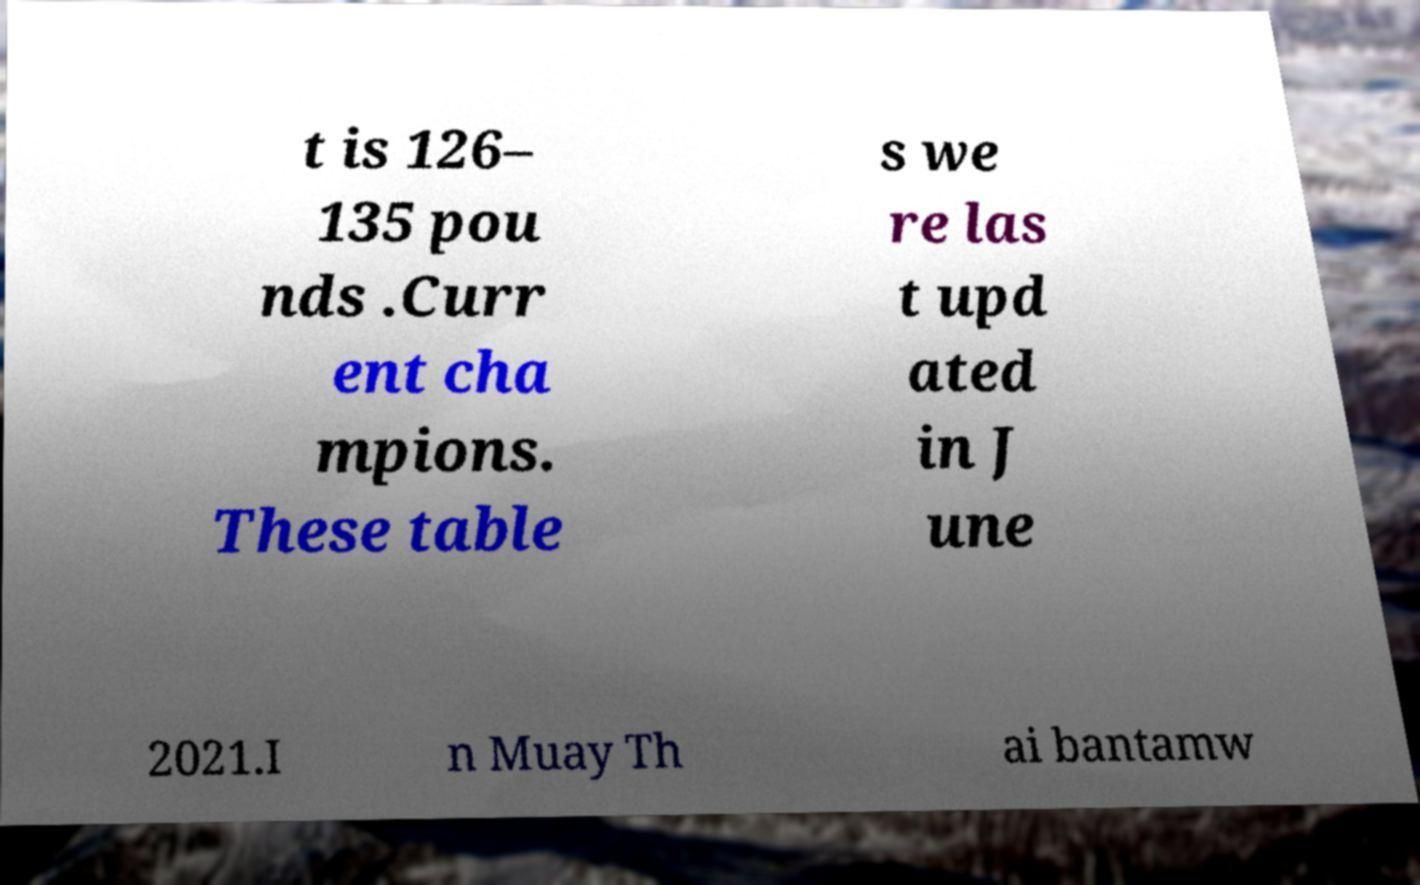For documentation purposes, I need the text within this image transcribed. Could you provide that? t is 126– 135 pou nds .Curr ent cha mpions. These table s we re las t upd ated in J une 2021.I n Muay Th ai bantamw 